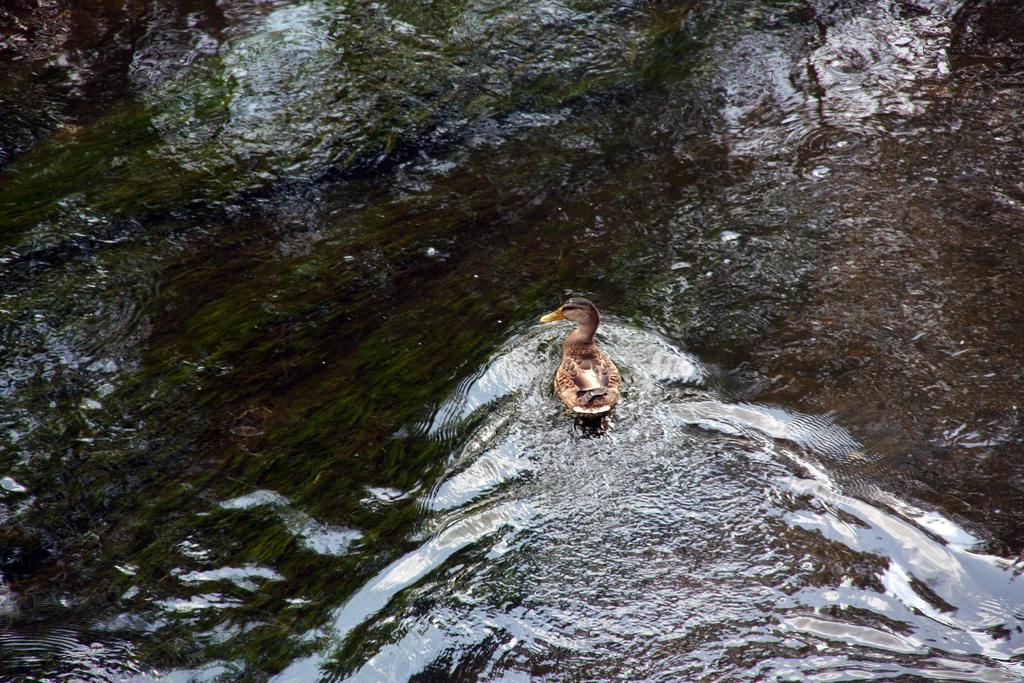What type of bird can be seen in the image? There is a brown and black color bird in the image. What is the bird standing on or near in the image? There is a black and brown color rock in the image. What else is visible in the image besides the bird and rock? There is water visible in the image. What type of glass can be seen in the image? There is no glass present in the image. What is the chin of the bird doing in the image? The bird does not have a chin, and therefore its chin cannot be observed in the image. 